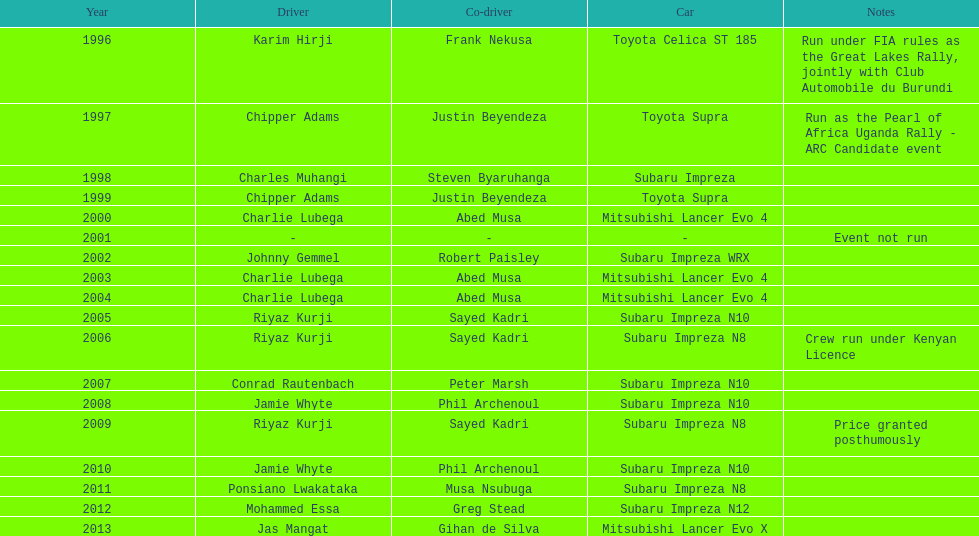Before the year 2004, how many times did a mitsubishi lancer claim a victory? 2. 